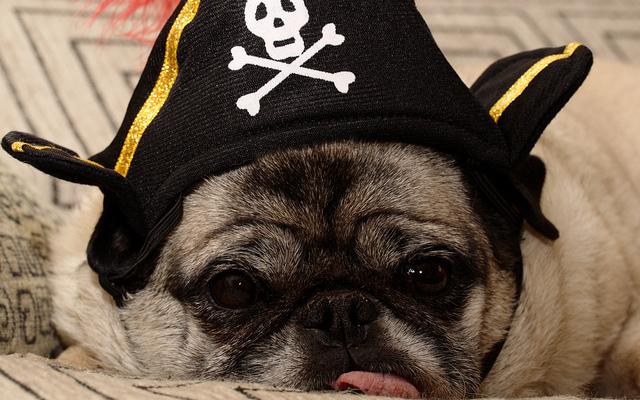Does this dog realizing it is wearing a hat?
Answer briefly. Yes. What human article of clothing is this dog wearing?
Short answer required. Hat. Is the dog tired?
Concise answer only. Yes. Is this a pirate?
Be succinct. No. What dog is this?
Write a very short answer. Pug. 